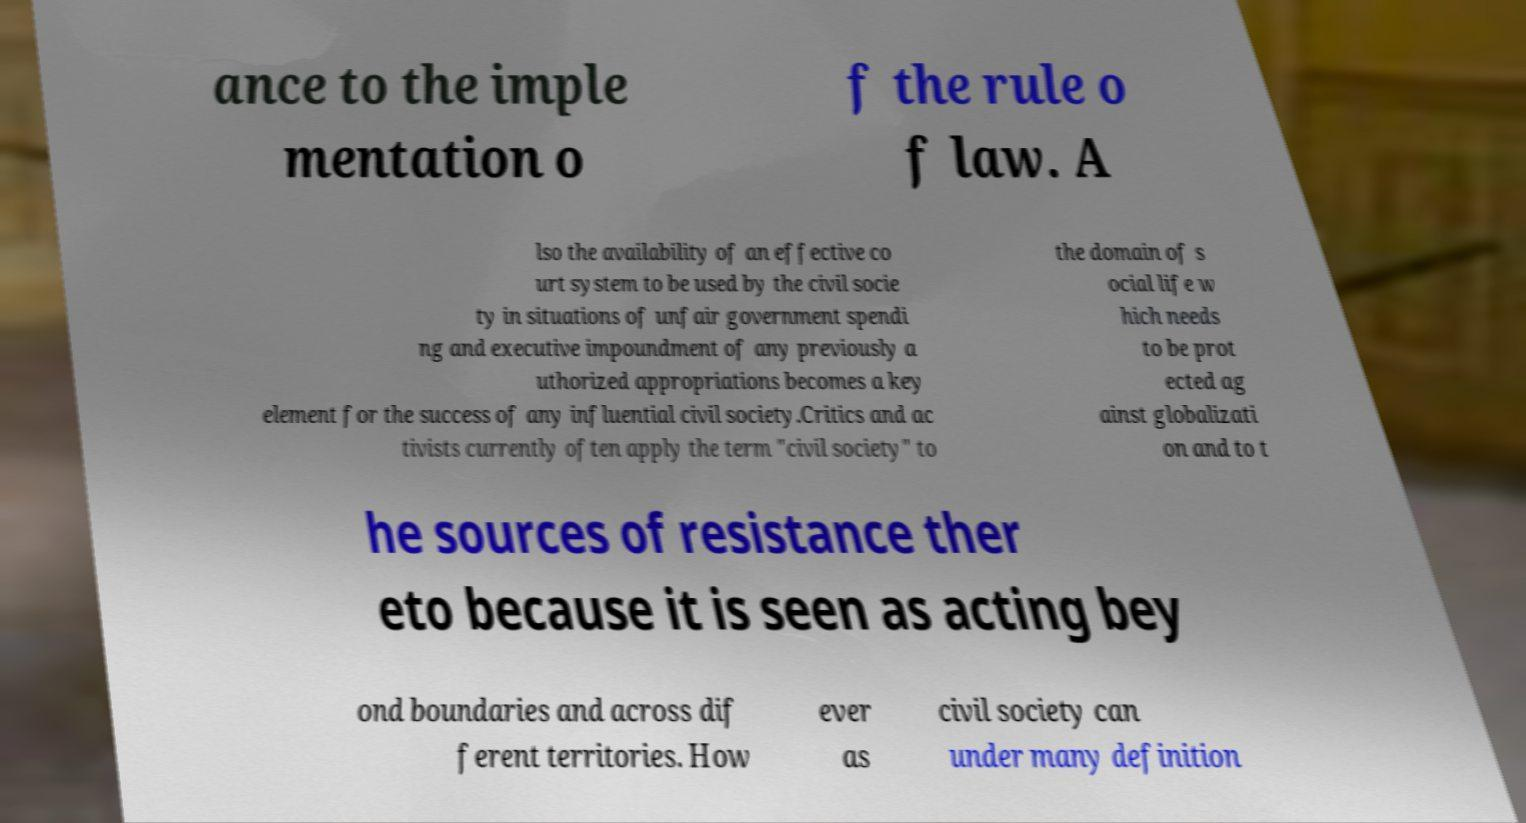For documentation purposes, I need the text within this image transcribed. Could you provide that? ance to the imple mentation o f the rule o f law. A lso the availability of an effective co urt system to be used by the civil socie ty in situations of unfair government spendi ng and executive impoundment of any previously a uthorized appropriations becomes a key element for the success of any influential civil society.Critics and ac tivists currently often apply the term "civil society" to the domain of s ocial life w hich needs to be prot ected ag ainst globalizati on and to t he sources of resistance ther eto because it is seen as acting bey ond boundaries and across dif ferent territories. How ever as civil society can under many definition 